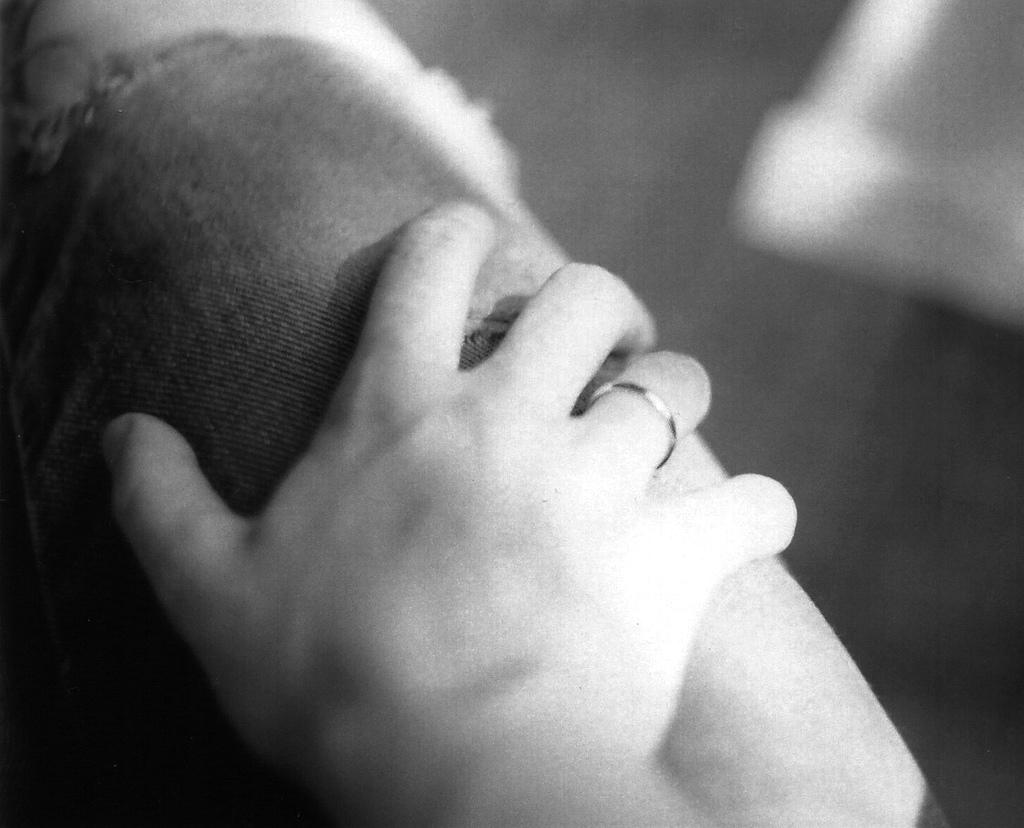What is the main focus of the image? The main focus of the image is a person's hand, which is visible in the center of the image. Can you describe the background of the image? The background of the image is blurred. What type of sea creature can be seen crawling out of the crate in the image? There is no sea creature or crate present in the image; it only features a person's hand and a blurred background. 